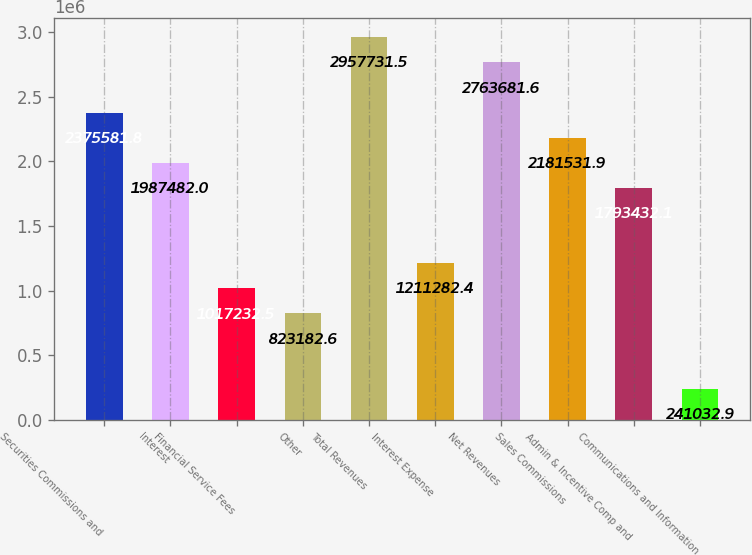Convert chart. <chart><loc_0><loc_0><loc_500><loc_500><bar_chart><fcel>Securities Commissions and<fcel>Interest<fcel>Financial Service Fees<fcel>Other<fcel>Total Revenues<fcel>Interest Expense<fcel>Net Revenues<fcel>Sales Commissions<fcel>Admin & Incentive Comp and<fcel>Communications and Information<nl><fcel>2.37558e+06<fcel>1.98748e+06<fcel>1.01723e+06<fcel>823183<fcel>2.95773e+06<fcel>1.21128e+06<fcel>2.76368e+06<fcel>2.18153e+06<fcel>1.79343e+06<fcel>241033<nl></chart> 